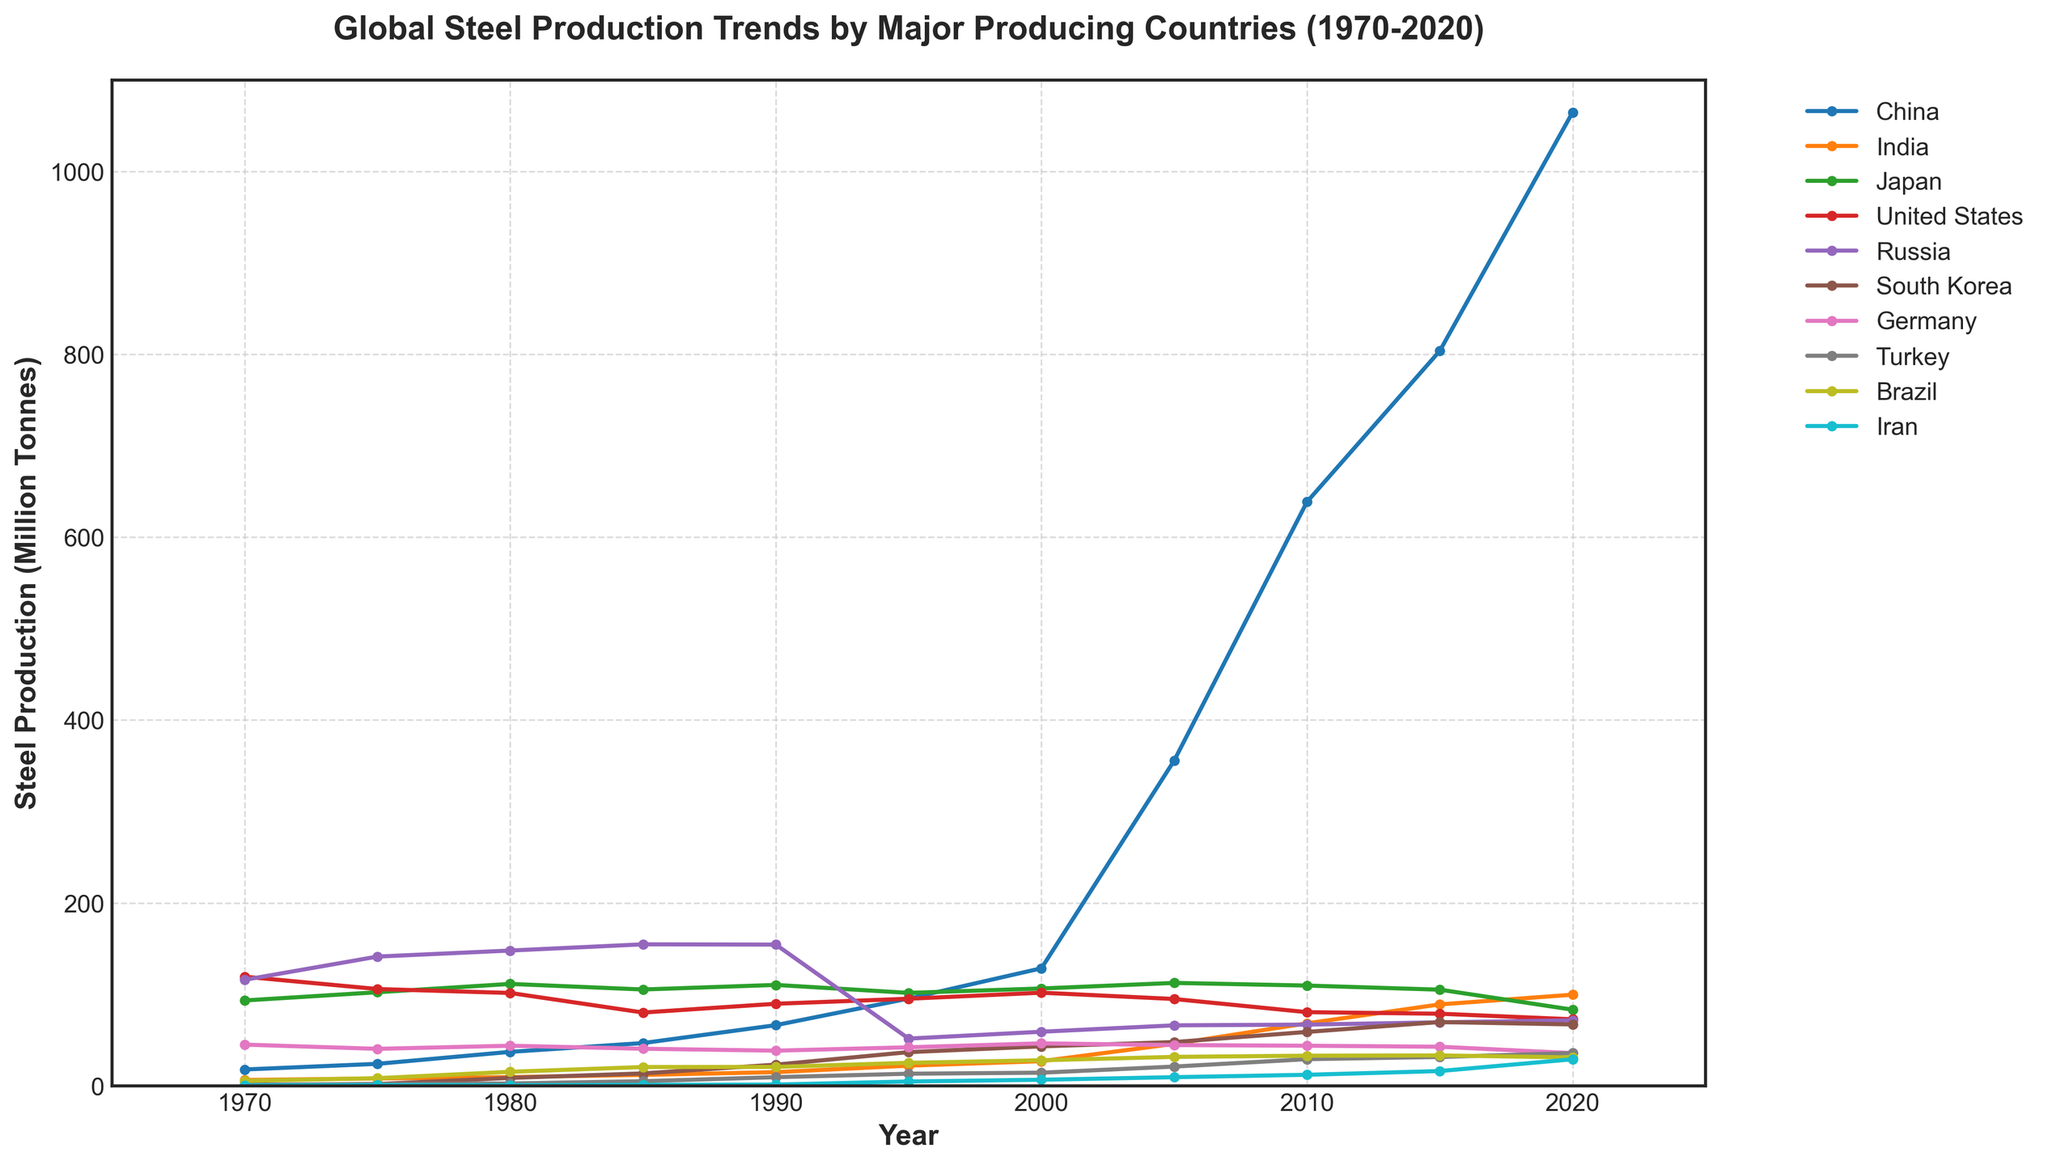When did China's steel production first surpass the United States'? To determine when China's steel production first surpassed that of the United States, look for the year when the line representing China crosses above the line representing the United States. This occurs between 2000 and 2005.
Answer: 2005 Which country had a steady decline in steel production from 2010 to 2020? To identify the country with a consistent decline, observe the trend lines between 2010 and 2020. The line representing Japan shows a steady decline during this period.
Answer: Japan In which year did India overtake Japan in steel production? Find the point where the line for India intersects and moves above the line for Japan. This happens between 2015 and 2020.
Answer: 2020 By how much did China's steel production increase from 2000 to 2020? Identify China's steel production values at 2000 and 2020, then calculate the difference: 1064.7 million tonnes in 2020 - 128.5 million tonnes in 2000.
Answer: 936.2 million tonnes How does South Korea's steel production in 2020 compare to that in 2000? Look at South Korea's production values in 2000 and 2020 and compare them. South Korea produced 43.1 million tonnes in 2000 and 67.1 million tonnes in 2020.
Answer: Increased by 24 million tonnes Which country had the highest production in 1990, and how much did it produce? Locate the peak values for each country in 1990. Russia had the highest production with approximately 154.4 million tonnes.
Answer: Russia, 154.4 million tonnes What is the average steel production of Germany from 1970 to 2020? Add Germany's production values across all years from 1970 to 2020, then divide by the number of years (11). The sum is 420.2 million tonnes, so the average is 420.2/11.
Answer: 38.2 million tonnes Identify the year in which Russia's steel production dropped below 100 million tonnes. Examine Russia's line for the point where its production falls below 100 million tonnes, which occurs between 1990 and 1995.
Answer: 1995 Compare Brazil's steel production in 1980 with that in 2010. Look at Brazil's production values in 1980 (15.3 million tonnes) and 2010 (32.9 million tonnes) and find the difference.
Answer: Increased by 17.6 million tonnes Between which years did Iran show the most significant increase in steel production? Observe the trend line for Iran and identify the period with the steepest slope. The significant increase happens from 2005 to 2010.
Answer: 2005 to 2010 